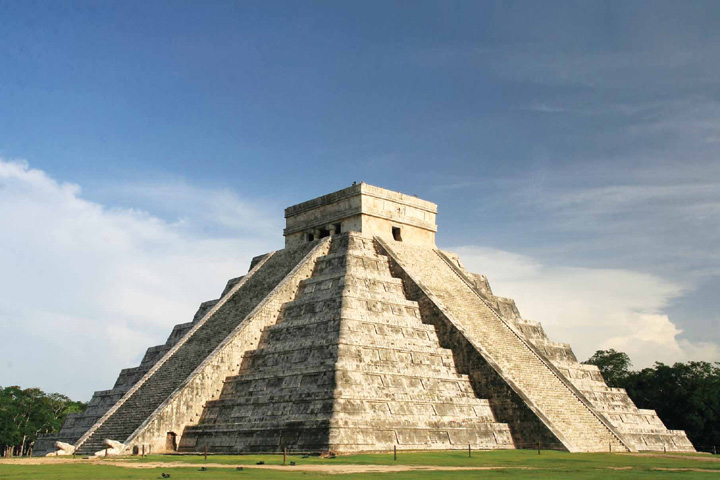Analyze the image in a comprehensive and detailed manner. The image features the iconic Chichen Itza, a pivotal relic of Mayan civilization in Yucatan, Mexico. This pyramid, known as El Castillo, stands prominently against a clear blue sky dotted with sparse clouds, illustrating a serene day. Each of the pyramid's four faces has a staircase ascending to a temple at the top, where rituals were performed. Surrounding the structure is a well-maintained lawn that highlights the pyramid's preserved state, inviting visitors and scholars to explore its historical narratives and architectural brilliance. The image not only captures the physical beauty of Chichen Itza but also subtly invites contemplation of its role in Mayan culture and its astronomical precision, evident in the shadow play during the equinox. 